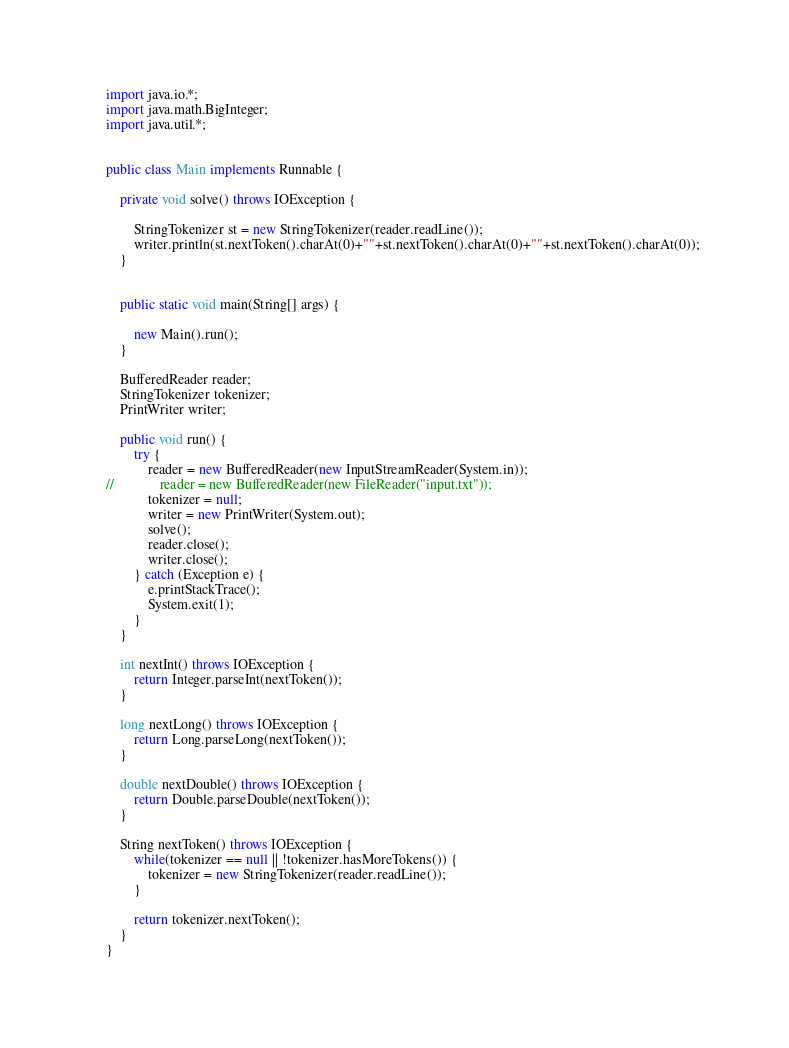Convert code to text. <code><loc_0><loc_0><loc_500><loc_500><_Java_>import java.io.*;
import java.math.BigInteger;
import java.util.*;


public class Main implements Runnable {

    private void solve() throws IOException {

        StringTokenizer st = new StringTokenizer(reader.readLine());
        writer.println(st.nextToken().charAt(0)+""+st.nextToken().charAt(0)+""+st.nextToken().charAt(0));
    }


    public static void main(String[] args) {

        new Main().run();
    }

    BufferedReader reader;
    StringTokenizer tokenizer;
    PrintWriter writer;

    public void run() {
        try {
            reader = new BufferedReader(new InputStreamReader(System.in));
//             reader = new BufferedReader(new FileReader("input.txt"));
            tokenizer = null;
            writer = new PrintWriter(System.out);
            solve();
            reader.close();
            writer.close();
        } catch (Exception e) {
            e.printStackTrace();
            System.exit(1);
        }
    }

    int nextInt() throws IOException {
        return Integer.parseInt(nextToken());
    }

    long nextLong() throws IOException {
        return Long.parseLong(nextToken());
    }

    double nextDouble() throws IOException {
        return Double.parseDouble(nextToken());
    }

    String nextToken() throws IOException {
        while(tokenizer == null || !tokenizer.hasMoreTokens()) {
            tokenizer = new StringTokenizer(reader.readLine());
        }

        return tokenizer.nextToken();
    }
}
</code> 